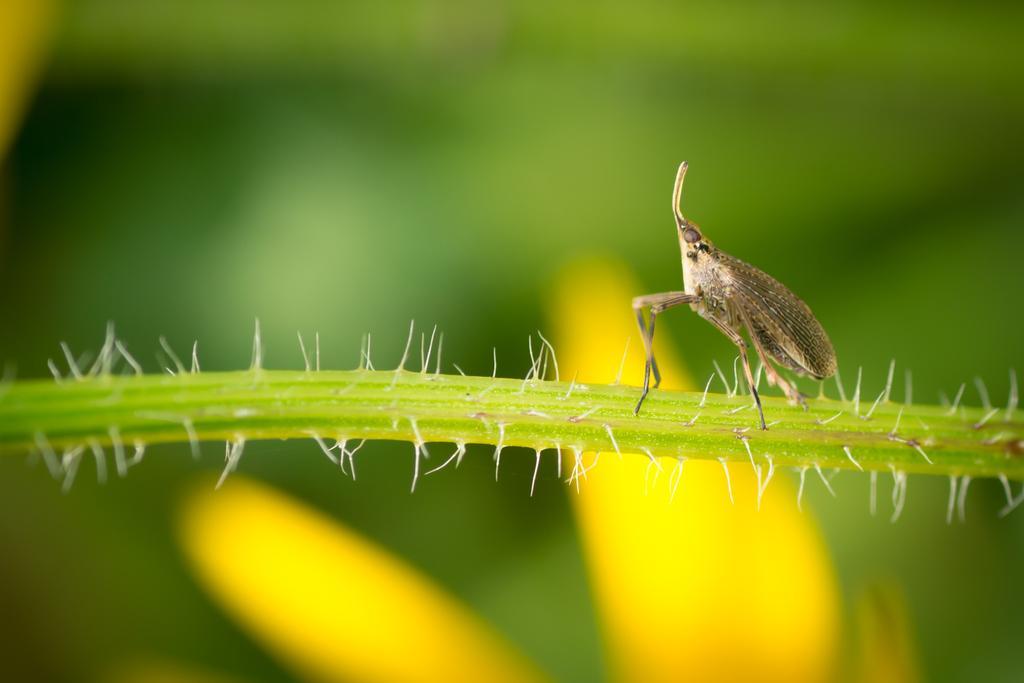Describe this image in one or two sentences. In this picture I can see an insect on the stem or branch , there are thorns, and there is blur background. 